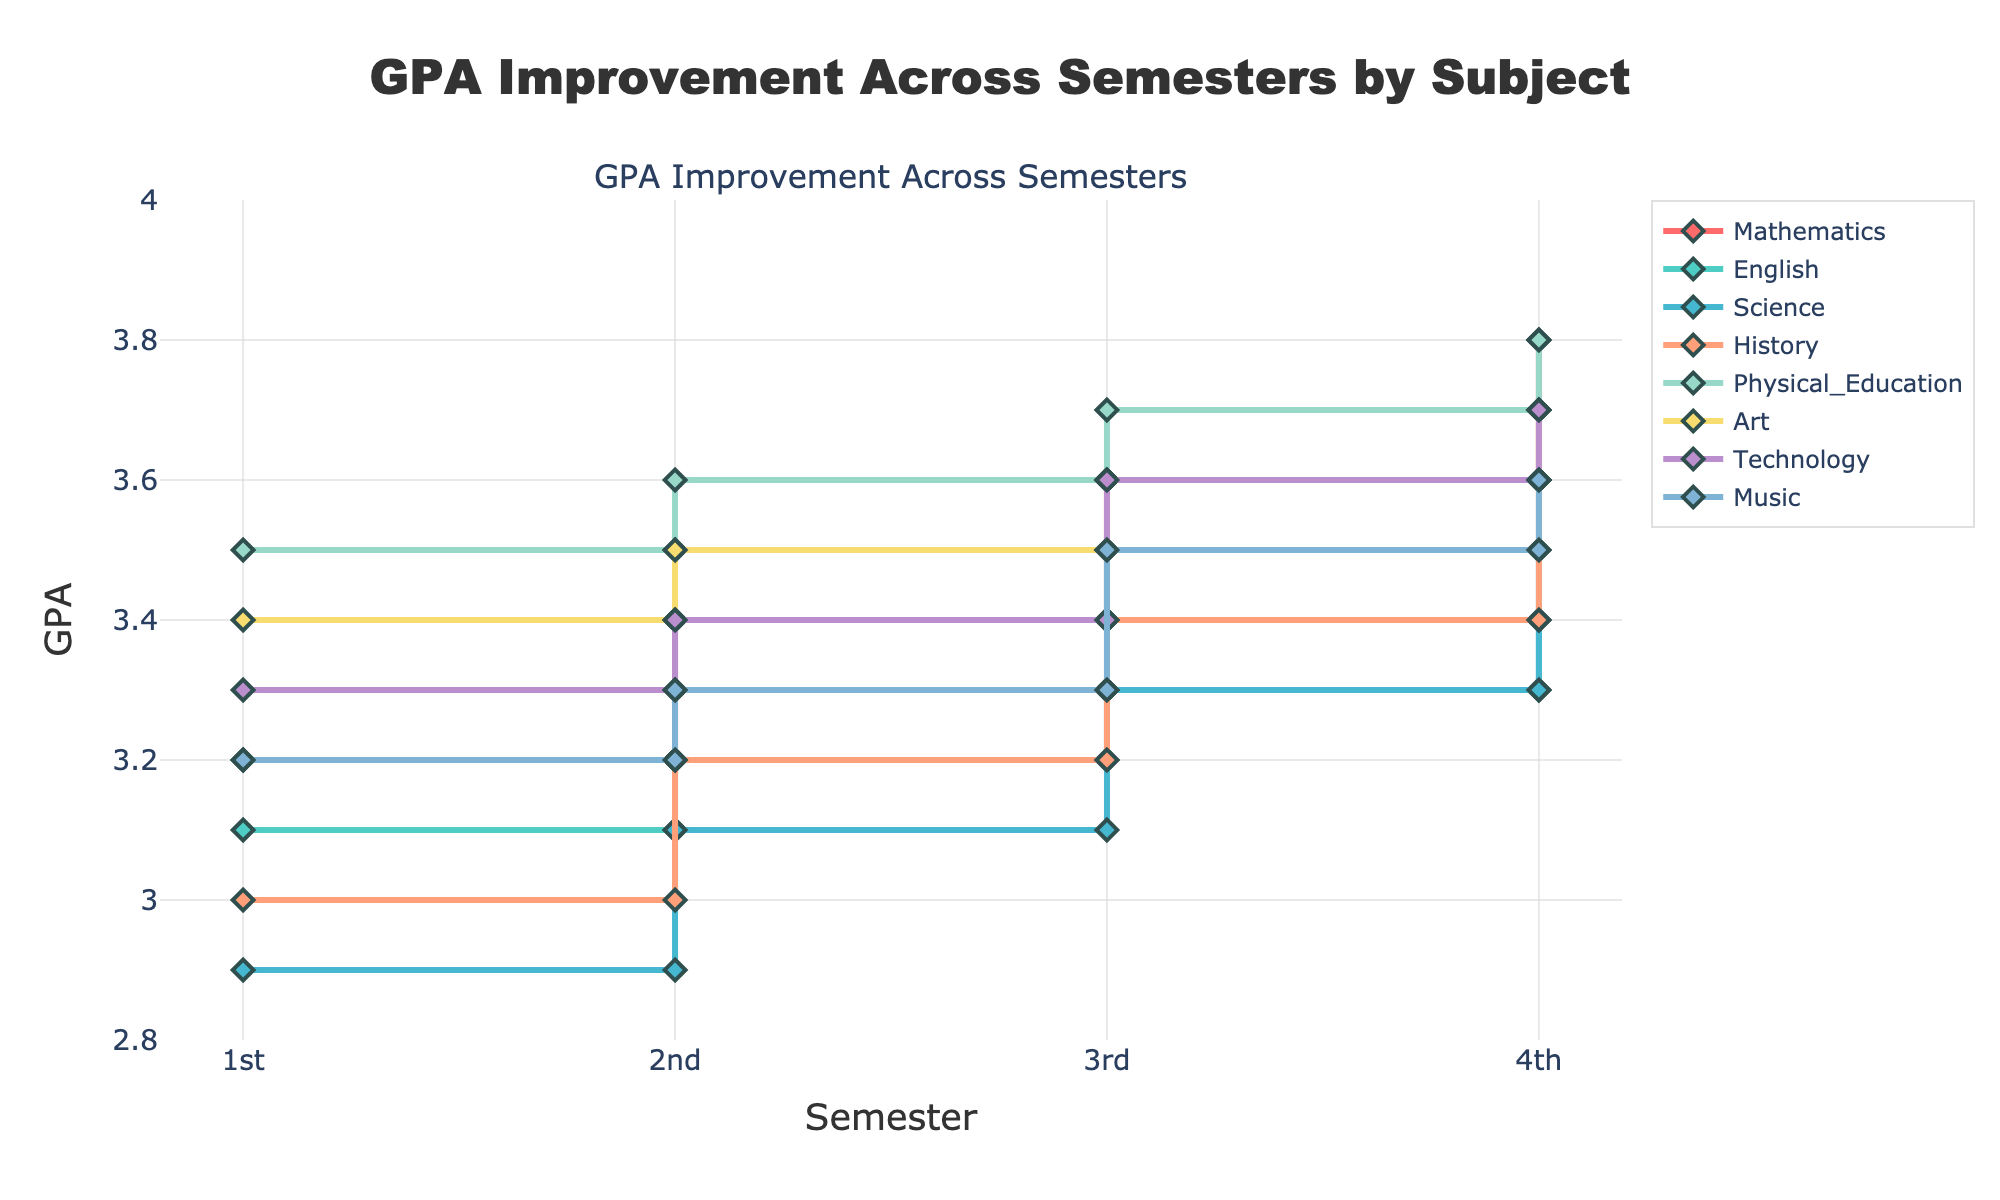What's the title of the figure? The title of the figure is written at the top center.
Answer: GPA Improvement Across Semesters by Subject How many subjects are displayed in the figure? Count the number of subjects listed in the legend on the right side of the figure.
Answer: 8 Which subject has the highest GPA increase from semester 1 to semester 4? Look at the end points of the lines for each subject; compare the GPA values from semester 1 to semester 4.
Answer: Mathematics By how much did the GPA in Science improve from semester 1 to semester 4? Subtract the GPA of Science in semester 1 from the GPA in semester 4 (3.4 - 2.9).
Answer: 0.5 Which subject had a consistent GPA improvement in every semester? Identify the subjects that show a constant upward trend (no GPA drop) over all semesters.
Answer: Mathematics, English, Science, History, Physical Education, Art, Technology, Music What was the GPA of Physical Education in the 3rd semester? Locate the GPA value of Physical Education at the 3rd semester on the graph.
Answer: 3.7 Which subject had the smallest increase in GPA from semester 2 to semester 3? Compare the second and third semester GPAs for all subjects and find the smallest difference.
Answer: Science Between Technology and Art, whose GPA increased more in the 4th semester compared to the 3rd semester? Compare the GPA increase between the 3rd and 4th semesters for both subjects.
Answer: Technology (0.1) What's the difference in GPA between Music and History in the 2nd semester? Subtract the GPA of History from Music in the 2nd semester (3.3 - 3.2).
Answer: 0.1 Which semester had the highest average GPA across all subjects? Calculate the average GPA for each semester and compare them to find the highest.
Answer: 4th semester 